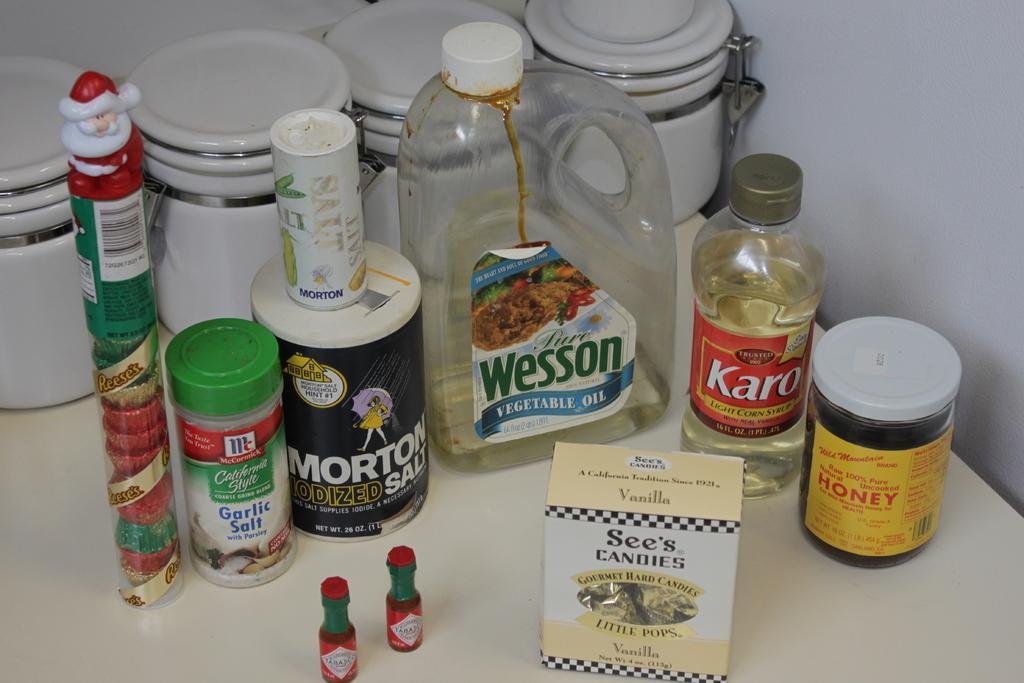How would you summarize this image in a sentence or two? In this image, few bottles and containers and box that are placed on the white table. At the background, we can see wall. 